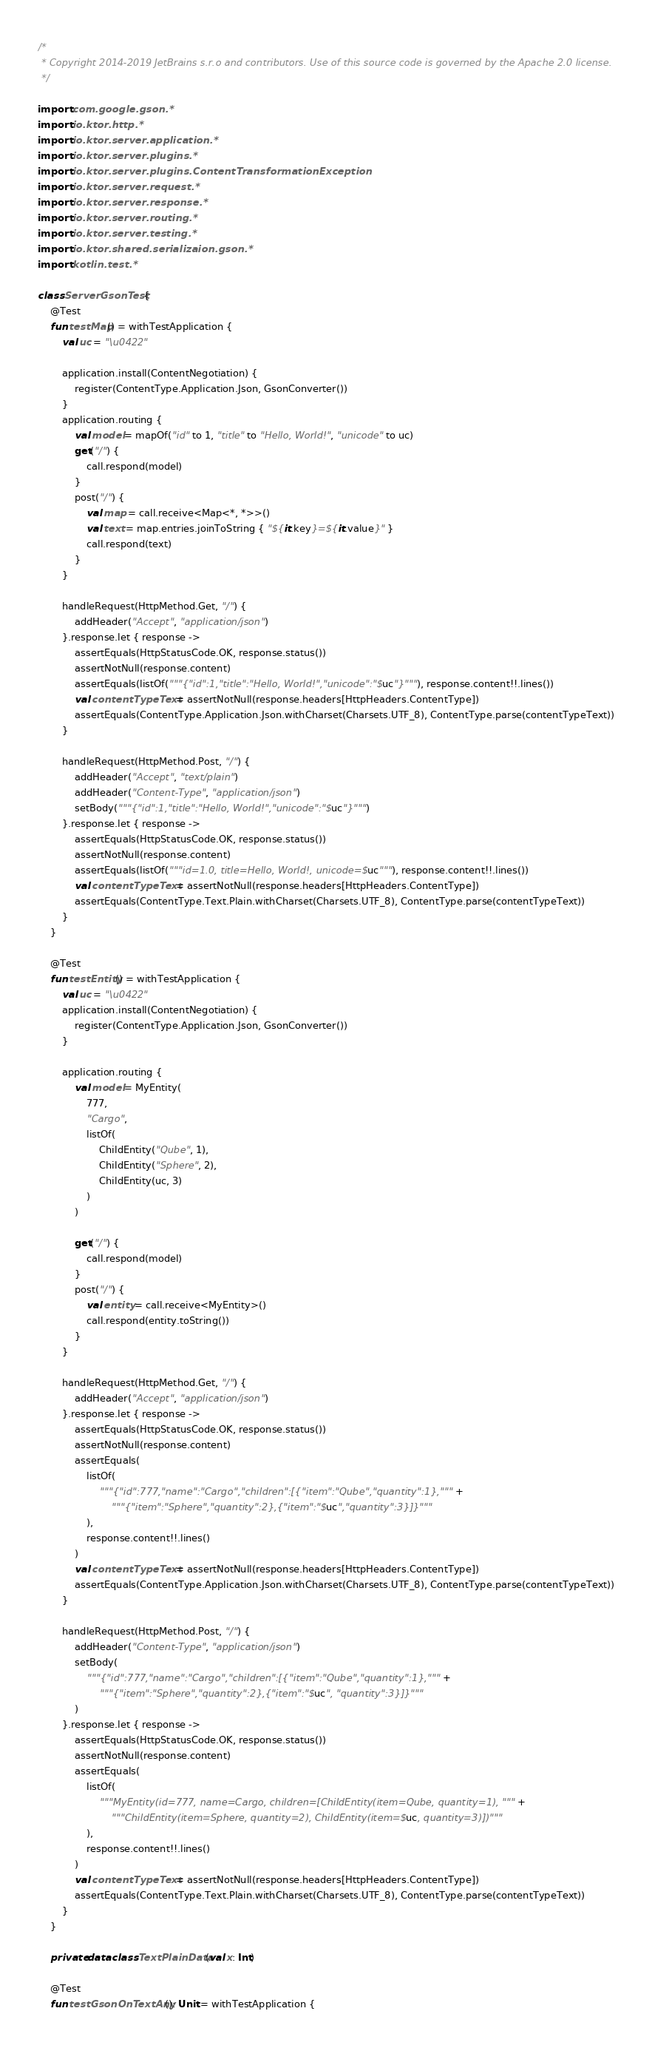<code> <loc_0><loc_0><loc_500><loc_500><_Kotlin_>/*
 * Copyright 2014-2019 JetBrains s.r.o and contributors. Use of this source code is governed by the Apache 2.0 license.
 */

import com.google.gson.*
import io.ktor.http.*
import io.ktor.server.application.*
import io.ktor.server.plugins.*
import io.ktor.server.plugins.ContentTransformationException
import io.ktor.server.request.*
import io.ktor.server.response.*
import io.ktor.server.routing.*
import io.ktor.server.testing.*
import io.ktor.shared.serializaion.gson.*
import kotlin.test.*

class ServerGsonTest {
    @Test
    fun testMap() = withTestApplication {
        val uc = "\u0422"

        application.install(ContentNegotiation) {
            register(ContentType.Application.Json, GsonConverter())
        }
        application.routing {
            val model = mapOf("id" to 1, "title" to "Hello, World!", "unicode" to uc)
            get("/") {
                call.respond(model)
            }
            post("/") {
                val map = call.receive<Map<*, *>>()
                val text = map.entries.joinToString { "${it.key}=${it.value}" }
                call.respond(text)
            }
        }

        handleRequest(HttpMethod.Get, "/") {
            addHeader("Accept", "application/json")
        }.response.let { response ->
            assertEquals(HttpStatusCode.OK, response.status())
            assertNotNull(response.content)
            assertEquals(listOf("""{"id":1,"title":"Hello, World!","unicode":"$uc"}"""), response.content!!.lines())
            val contentTypeText = assertNotNull(response.headers[HttpHeaders.ContentType])
            assertEquals(ContentType.Application.Json.withCharset(Charsets.UTF_8), ContentType.parse(contentTypeText))
        }

        handleRequest(HttpMethod.Post, "/") {
            addHeader("Accept", "text/plain")
            addHeader("Content-Type", "application/json")
            setBody("""{"id":1,"title":"Hello, World!","unicode":"$uc"}""")
        }.response.let { response ->
            assertEquals(HttpStatusCode.OK, response.status())
            assertNotNull(response.content)
            assertEquals(listOf("""id=1.0, title=Hello, World!, unicode=$uc"""), response.content!!.lines())
            val contentTypeText = assertNotNull(response.headers[HttpHeaders.ContentType])
            assertEquals(ContentType.Text.Plain.withCharset(Charsets.UTF_8), ContentType.parse(contentTypeText))
        }
    }

    @Test
    fun testEntity() = withTestApplication {
        val uc = "\u0422"
        application.install(ContentNegotiation) {
            register(ContentType.Application.Json, GsonConverter())
        }

        application.routing {
            val model = MyEntity(
                777,
                "Cargo",
                listOf(
                    ChildEntity("Qube", 1),
                    ChildEntity("Sphere", 2),
                    ChildEntity(uc, 3)
                )
            )

            get("/") {
                call.respond(model)
            }
            post("/") {
                val entity = call.receive<MyEntity>()
                call.respond(entity.toString())
            }
        }

        handleRequest(HttpMethod.Get, "/") {
            addHeader("Accept", "application/json")
        }.response.let { response ->
            assertEquals(HttpStatusCode.OK, response.status())
            assertNotNull(response.content)
            assertEquals(
                listOf(
                    """{"id":777,"name":"Cargo","children":[{"item":"Qube","quantity":1},""" +
                        """{"item":"Sphere","quantity":2},{"item":"$uc","quantity":3}]}"""
                ),
                response.content!!.lines()
            )
            val contentTypeText = assertNotNull(response.headers[HttpHeaders.ContentType])
            assertEquals(ContentType.Application.Json.withCharset(Charsets.UTF_8), ContentType.parse(contentTypeText))
        }

        handleRequest(HttpMethod.Post, "/") {
            addHeader("Content-Type", "application/json")
            setBody(
                """{"id":777,"name":"Cargo","children":[{"item":"Qube","quantity":1},""" +
                    """{"item":"Sphere","quantity":2},{"item":"$uc", "quantity":3}]}"""
            )
        }.response.let { response ->
            assertEquals(HttpStatusCode.OK, response.status())
            assertNotNull(response.content)
            assertEquals(
                listOf(
                    """MyEntity(id=777, name=Cargo, children=[ChildEntity(item=Qube, quantity=1), """ +
                        """ChildEntity(item=Sphere, quantity=2), ChildEntity(item=$uc, quantity=3)])"""
                ),
                response.content!!.lines()
            )
            val contentTypeText = assertNotNull(response.headers[HttpHeaders.ContentType])
            assertEquals(ContentType.Text.Plain.withCharset(Charsets.UTF_8), ContentType.parse(contentTypeText))
        }
    }

    private data class TextPlainData(val x: Int)

    @Test
    fun testGsonOnTextAny(): Unit = withTestApplication {</code> 